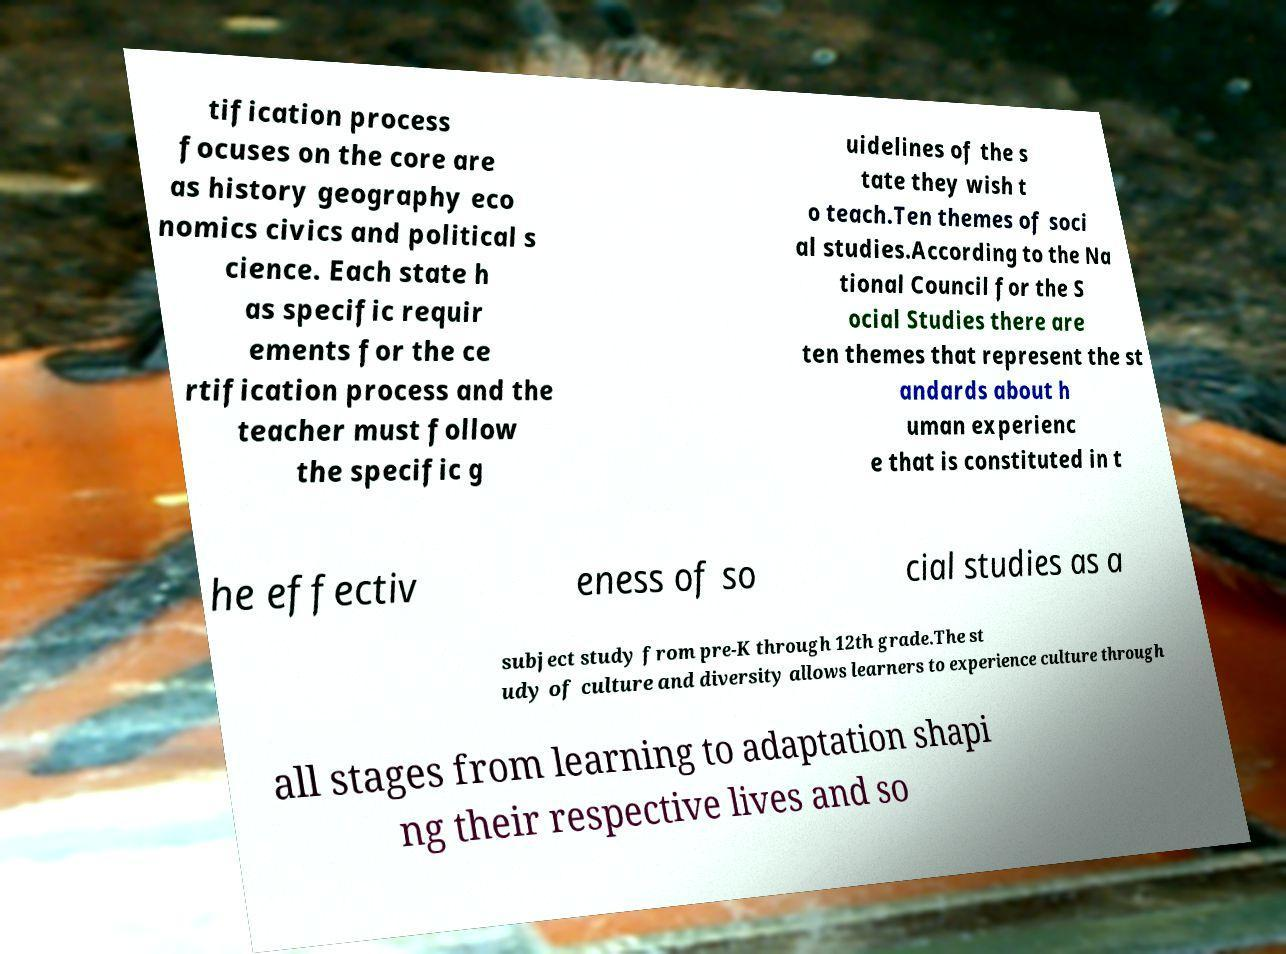Can you accurately transcribe the text from the provided image for me? tification process focuses on the core are as history geography eco nomics civics and political s cience. Each state h as specific requir ements for the ce rtification process and the teacher must follow the specific g uidelines of the s tate they wish t o teach.Ten themes of soci al studies.According to the Na tional Council for the S ocial Studies there are ten themes that represent the st andards about h uman experienc e that is constituted in t he effectiv eness of so cial studies as a subject study from pre-K through 12th grade.The st udy of culture and diversity allows learners to experience culture through all stages from learning to adaptation shapi ng their respective lives and so 